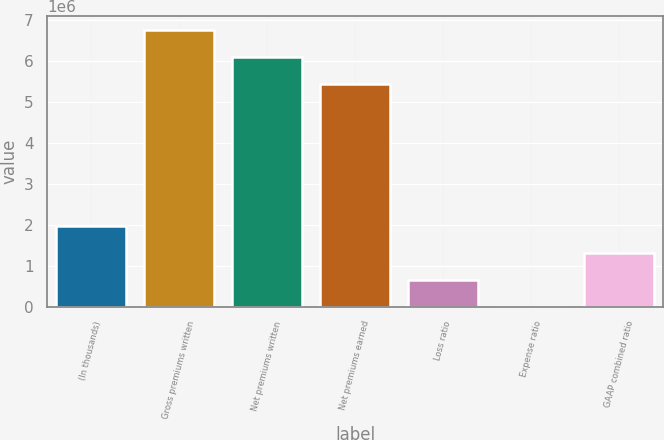Convert chart to OTSL. <chart><loc_0><loc_0><loc_500><loc_500><bar_chart><fcel>(In thousands)<fcel>Gross premiums written<fcel>Net premiums written<fcel>Net premiums earned<fcel>Loss ratio<fcel>Expense ratio<fcel>GAAP combined ratio<nl><fcel>1.98227e+06<fcel>6.75299e+06<fcel>6.09225e+06<fcel>5.4315e+06<fcel>660779<fcel>32.6<fcel>1.32152e+06<nl></chart> 